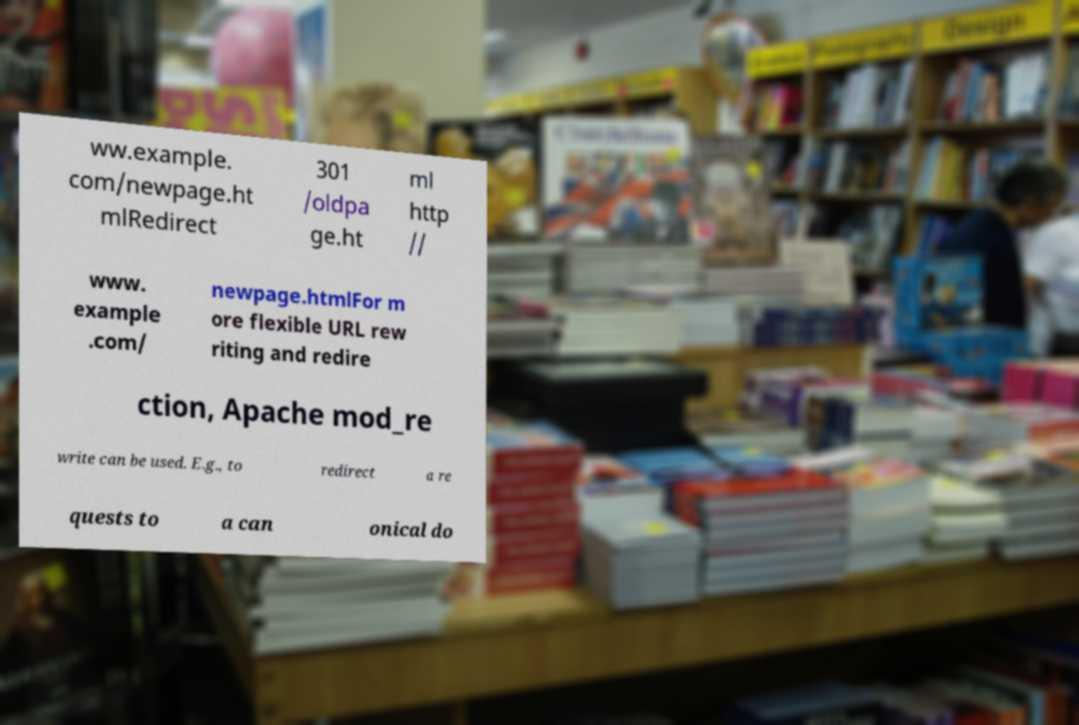Please identify and transcribe the text found in this image. ww.example. com/newpage.ht mlRedirect 301 /oldpa ge.ht ml http // www. example .com/ newpage.htmlFor m ore flexible URL rew riting and redire ction, Apache mod_re write can be used. E.g., to redirect a re quests to a can onical do 